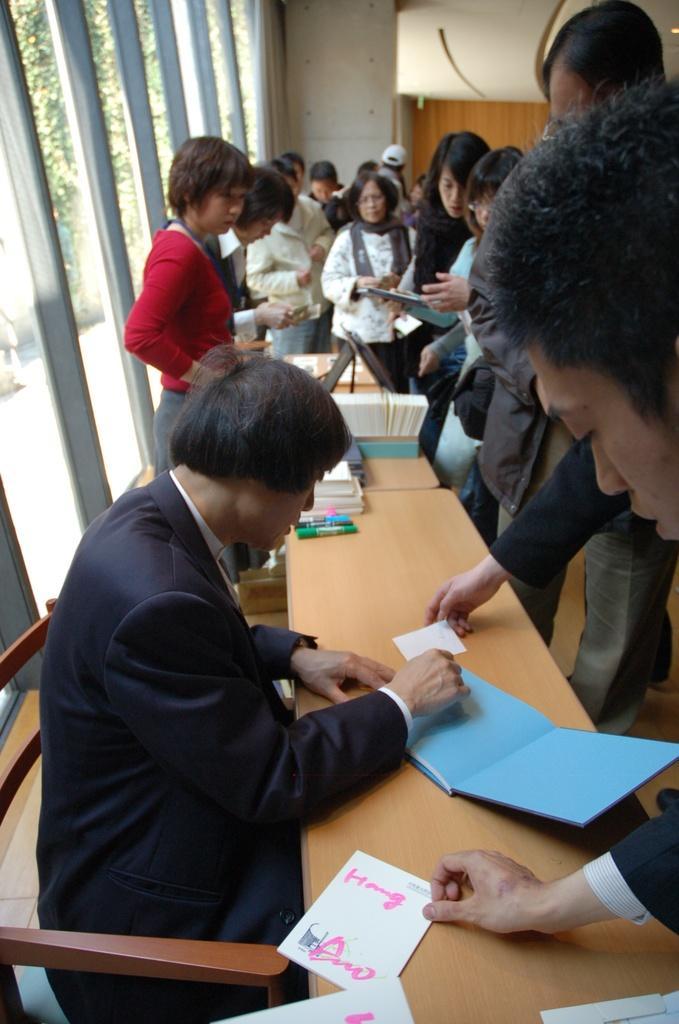In one or two sentences, can you explain what this image depicts? In the image we can see there are people sitting and others are standing. On the table there papers, sketches and book. 